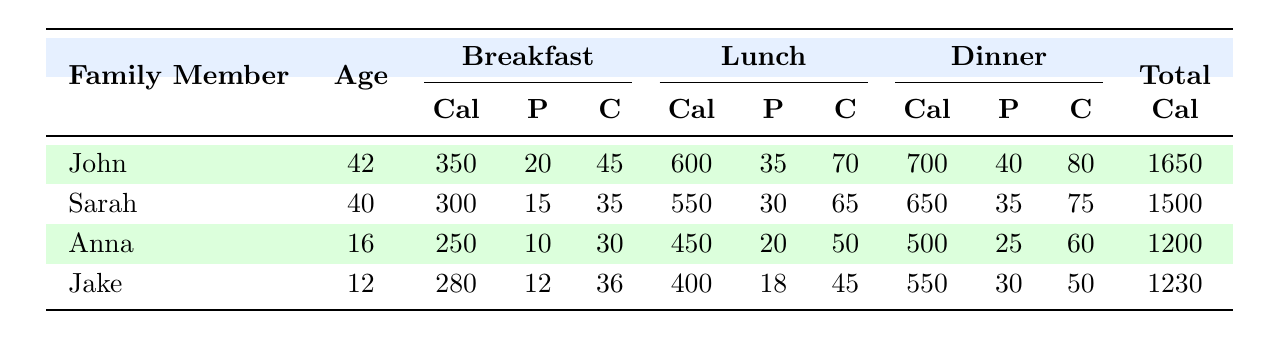What is Jake's total calorie intake for the day? To find Jake's total calorie intake, we need to sum the calorie values for each meal: Breakfast (280), Lunch (400), and Dinner (550). Adding these together gives us 280 + 400 + 550 = 1230.
Answer: 1230 How many grams of protein does Sarah consume at lunch? The table shows that Sarah consumes 30 grams of protein at lunch.
Answer: 30 Which family member consumes the most calories at dinner? Looking at the dinner calorie values, John has 700 calories, Sarah has 650, Anna has 500, and Jake has 550. Since John's 700 calories is the highest value, he consumes the most at dinner.
Answer: John What is the average carbohydrate intake for breakfast across all family members? First, we find the carbohydrate values for breakfast: John (45), Sarah (35), Anna (30), and Jake (36). Summing these gives 45 + 35 + 30 + 36 = 146. There are 4 family members, so we divide 146 by 4, resulting in an average of 36.5.
Answer: 36.5 Did Anna consume more protein at dinner than Jake? Anna's protein intake at dinner is 25 grams, while Jake's is 30 grams. Since 25 is less than 30, the statement is false.
Answer: No Which meal has the highest total caloric intake among all family members? Summing the total calories for each meal type: Breakfast (350 + 300 + 250 + 280 = 1180), Lunch (600 + 550 + 450 + 400 = 2000), and Dinner (700 + 650 + 500 + 550 = 2400). The dinner has the highest calorie intake at 2400.
Answer: Dinner If the family aimed for a total calorie count of 6000 across all three meals, did they meet their goal? Each family member's total calories are: John (1650), Sarah (1500), Anna (1200), and Jake (1230). Adding these up gives 1650 + 1500 + 1200 + 1230 = 4580. Since 4580 is less than the goal of 6000, they did not meet it.
Answer: No What is the total amount of protein consumed by the family during lunch? Adding the protein amounts from lunch: John (35), Sarah (30), Anna (20), and Jake (18) gives 35 + 30 + 20 + 18 = 103 grams of protein.
Answer: 103 Which family member has the highest protein intake for breakfast? The protein amounts for breakfast are: John (20), Sarah (15), Anna (10), and Jake (12). John has the highest protein intake of 20 grams at breakfast.
Answer: John 